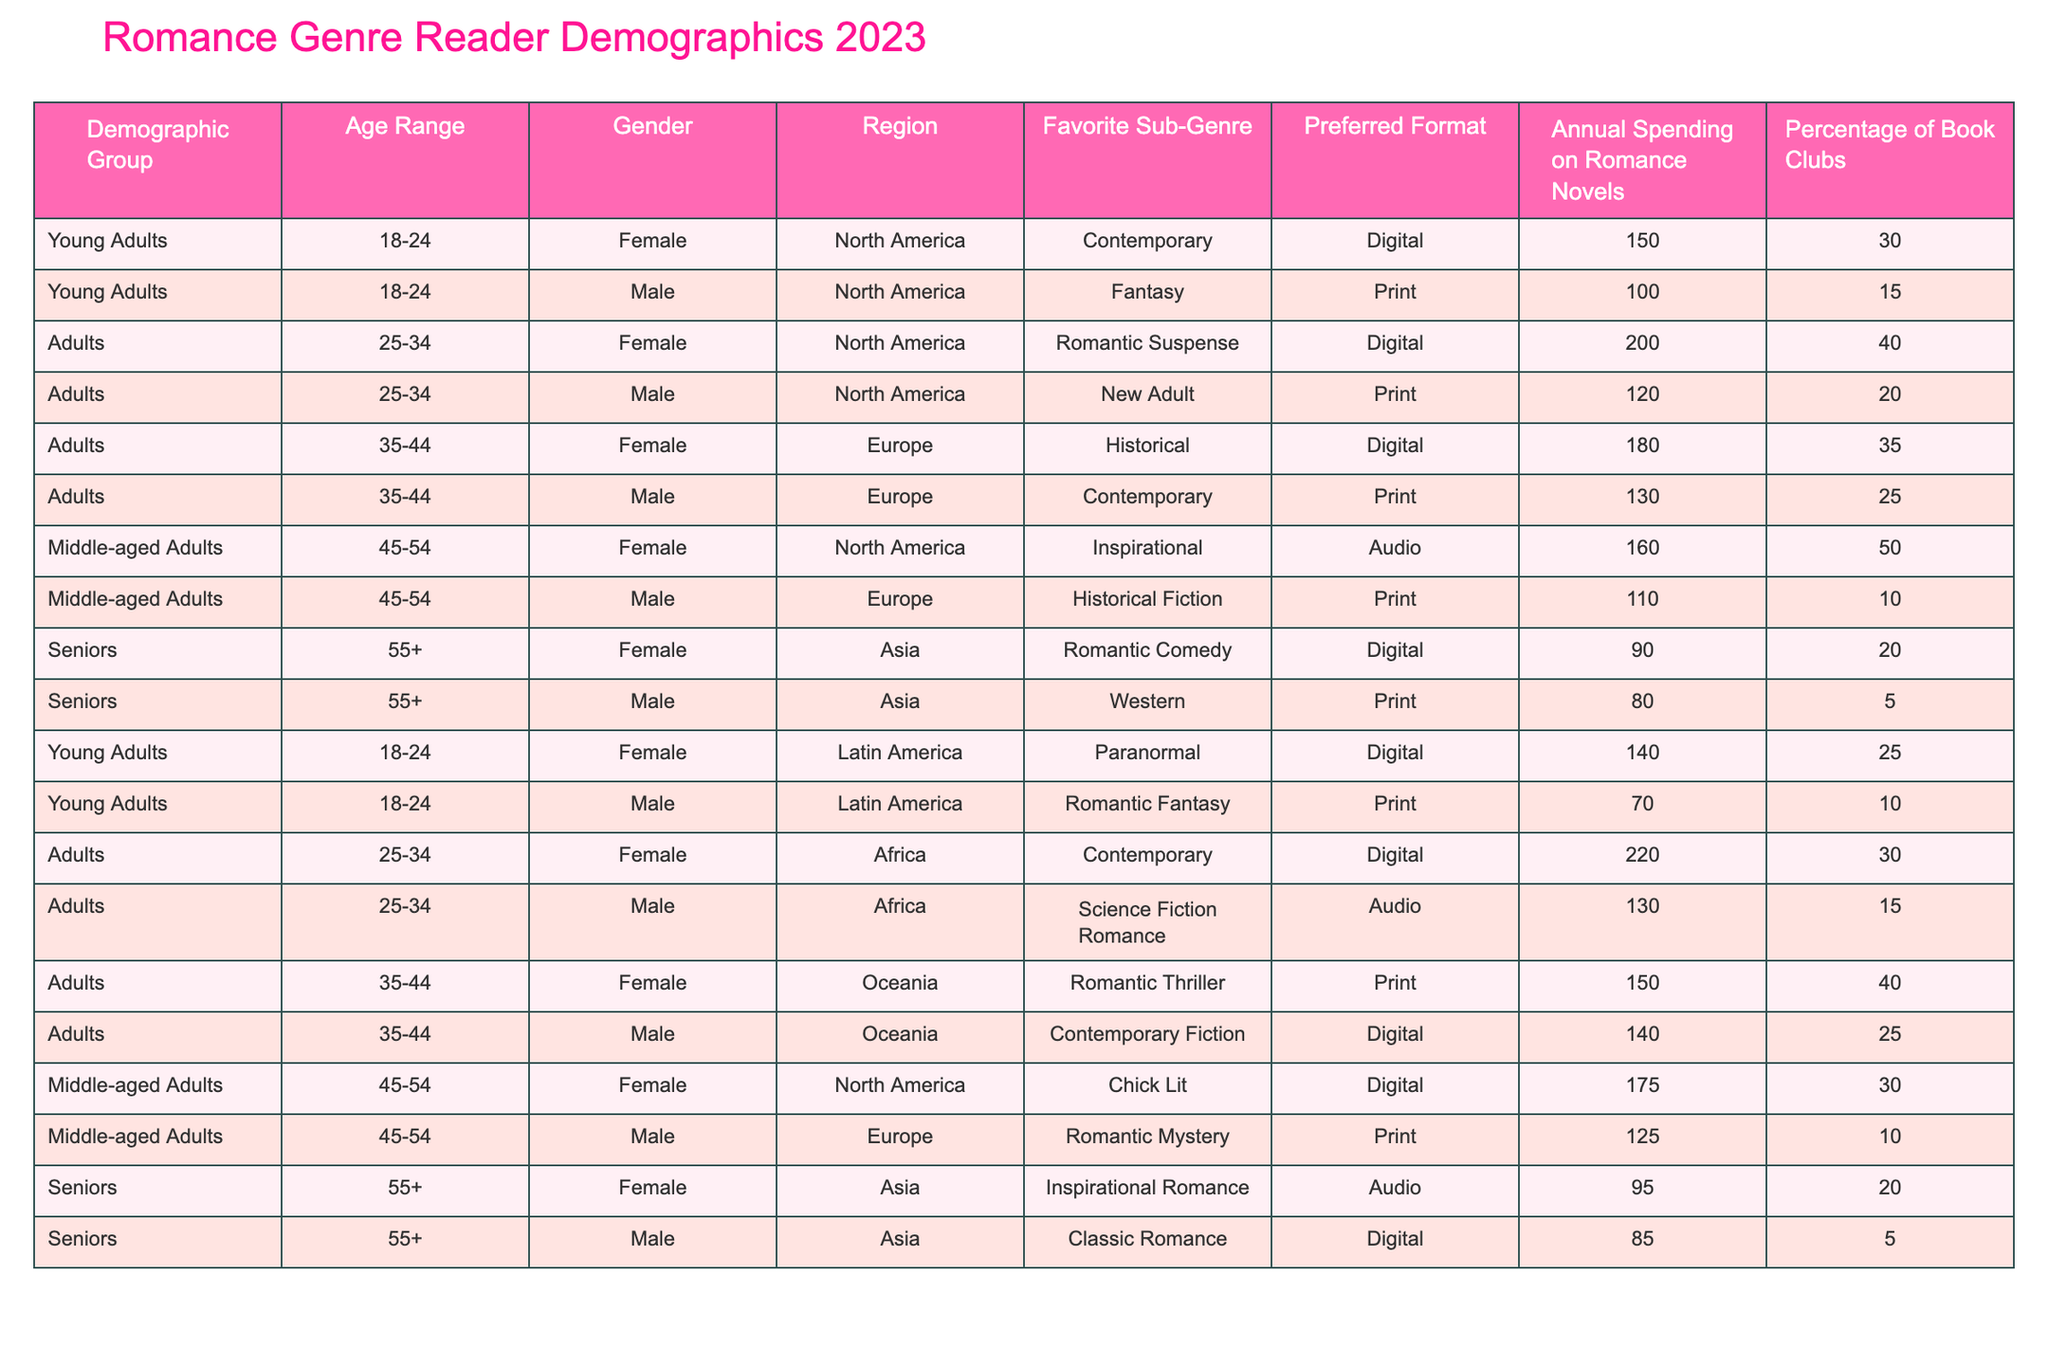What is the favorite sub-genre of male readers aged 45-54 in Europe? According to the table, the favorite sub-genre of male readers aged 45-54 in Europe is Historical Fiction.
Answer: Historical Fiction What is the total annual spending on romance novels by female readers in the age range of 25-34 across all regions? Adding up the annual spending by female readers aged 25-34 from different regions: 200 (North America) + 220 (Africa) = 420.
Answer: 420 What percentage of young adult female readers are part of book clubs? The table shows that 30% of young adult female readers in North America are part of book clubs.
Answer: 30% Which region has the highest average annual spending on romance novels for male readers in the age range of 35-44? The average annual spending for males aged 35-44 is calculated as (130 + 140) / 2 = 135 in Europe and (150) in Oceania. Thus, Oceania has the highest average.
Answer: Oceania Do female readers aged 55 and older in Asia prefer digital formats? The table indicates that female readers aged 55 and older have chosen audio formats (Inspirational Romance) and digital formats (Classic Romance), indicating they do not primarily prefer digital formats.
Answer: No How much does the average spending on romance novels differ between young adult males in North America and Latin America? The spending for North American males is 100, while for Latin American males it is 70. The difference is 100 - 70 = 30.
Answer: 30 What is the favorite sub-genre for seniors aged 55 and older in Asia? For seniors aged 55 and older in Asia, the favorite sub-genres are Romantic Comedy and Inspirational Romance, both mentioned in the table.
Answer: Romantic Comedy and Inspirational Romance How many males aged 35-44 in North America have a favorite sub-genre in Contemporary? The table indicates that there is one male reader aged 35-44 in North America who has a favorite sub-genre in Contemporary.
Answer: 1 Which demographic group has the highest representation in book clubs? The table shows that Middle-aged Adults (45-54) have 50% representation in book clubs, which is the highest percentage compared to other groups.
Answer: Middle-aged Adults (45-54) What is the combined annual spending on romance novels for middle-aged adults 45-54 across all regions? The spending for female readers is 160 (North America) + 175 (North America) = 335, and for male readers is 110 (Europe) + 125 (Europe) = 235. Combined total = 335 + 235 = 570.
Answer: 570 